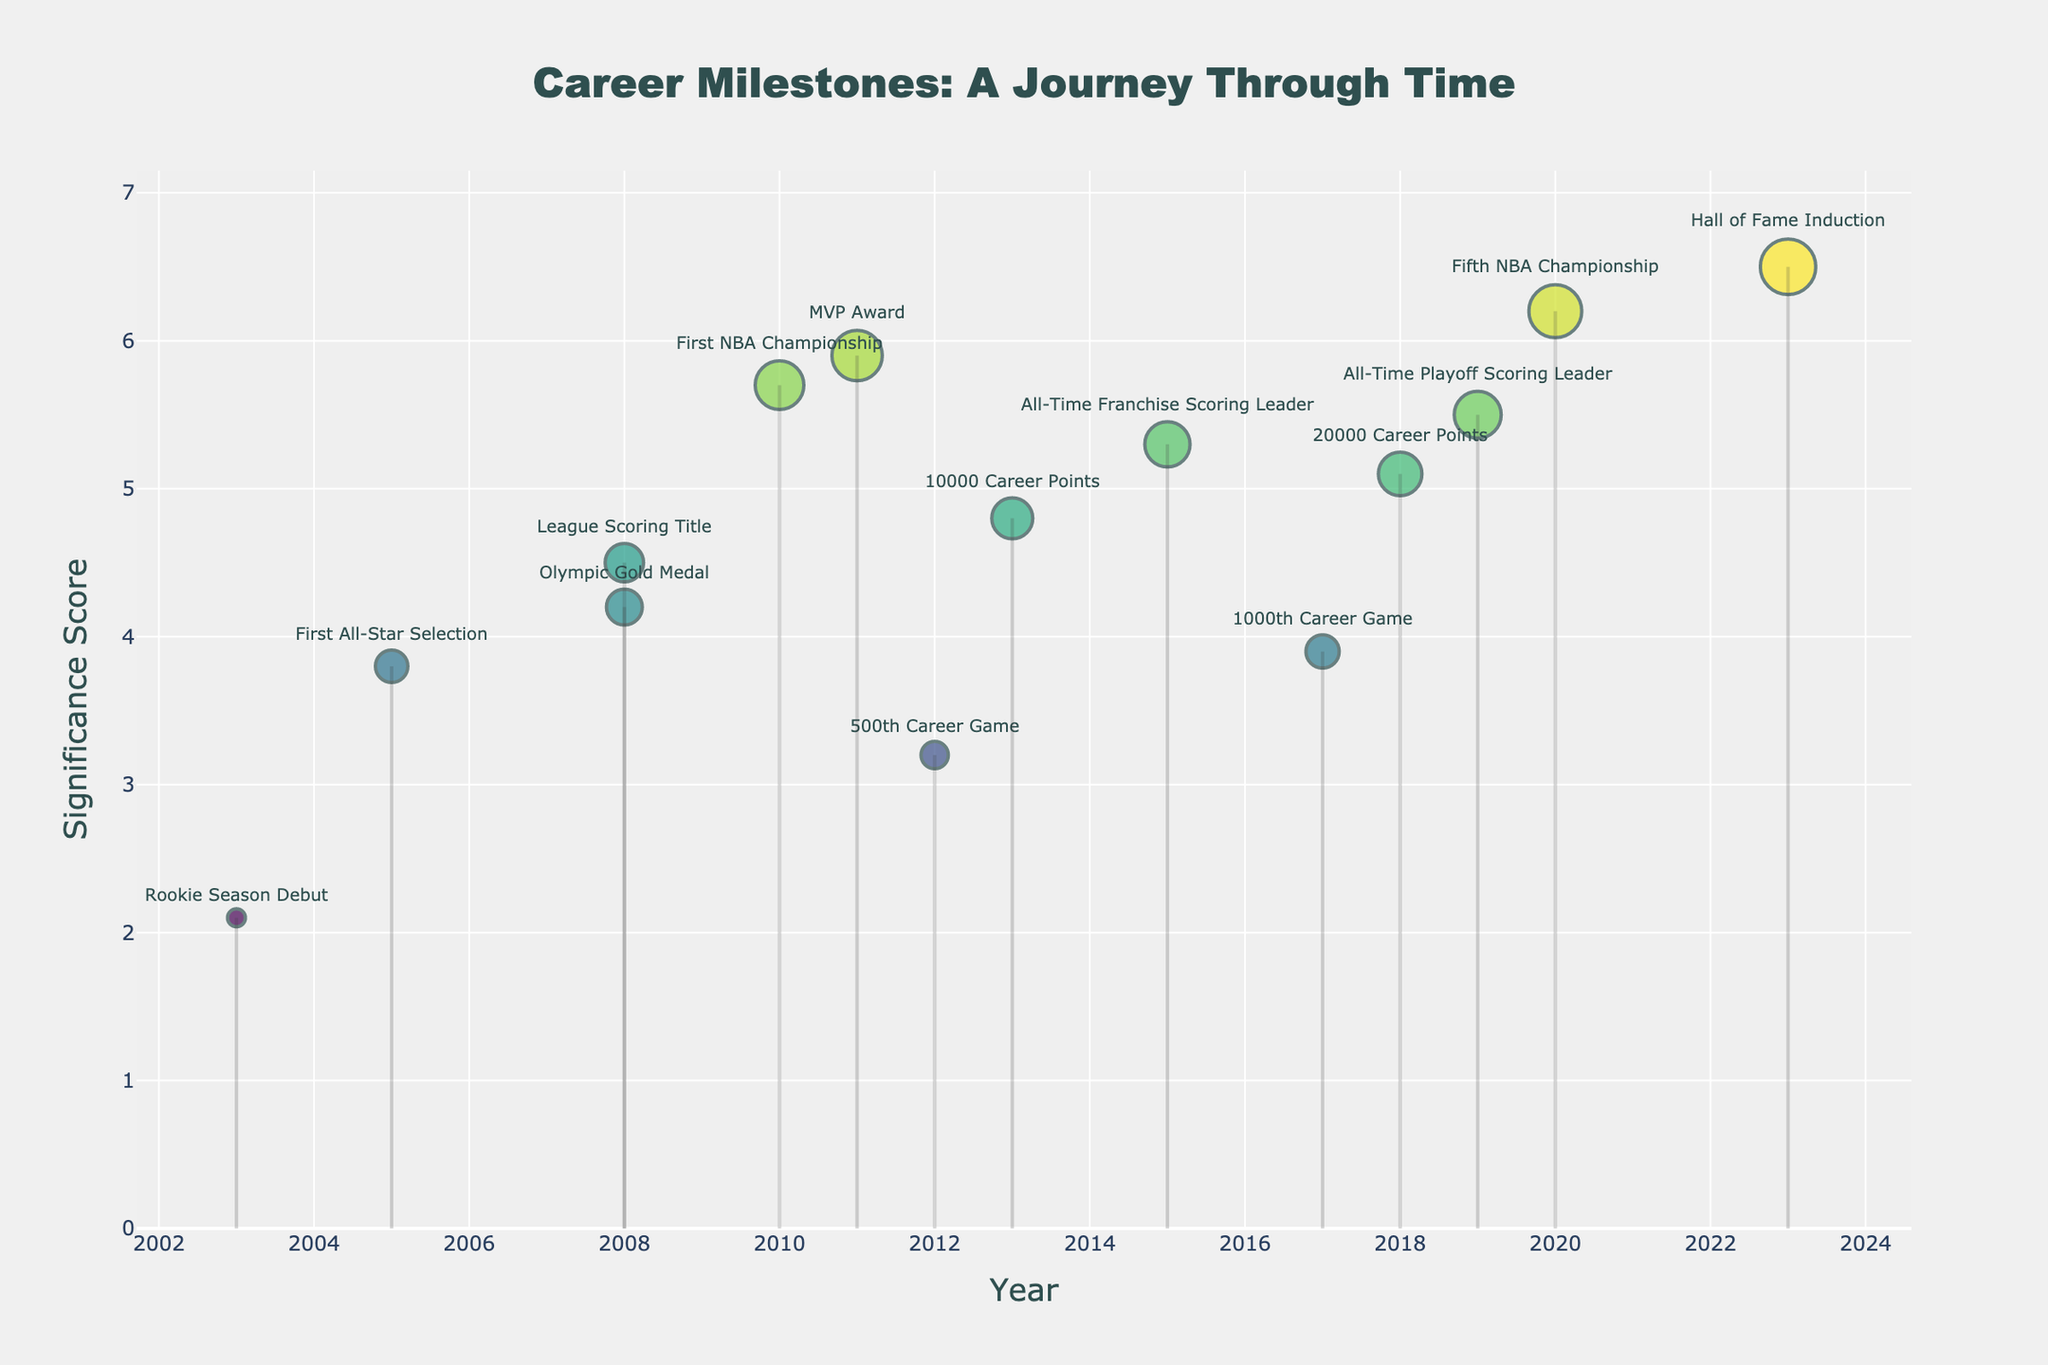What is the title of the plot? The title is usually positioned at the top of the plot. In this case, it reads "Career Milestones: A Journey Through Time".
Answer: Career Milestones: A Journey Through Time What is the significance score of the Hall of Fame Induction? The Hall of Fame Induction is one of the milestones labeled in the plot. The significance score associated with it can be found next to its marker.
Answer: 6.5 Which milestone has the highest significance score? By looking at all the markers on the plot, the one with the highest significance score will be the one with the greatest y-value. In this case, it is the Hall of Fame Induction.
Answer: Hall of Fame Induction How many milestones have a significance score greater than 5.0? Count the number of markers positioned above the significance score line of 5.0. These milestones include First NBA Championship, MVP Award, All-Time Franchise Scoring Leader, 20000 Career Points, All-Time Playoff Scoring Leader, Fifth NBA Championship, and Hall of Fame Induction. There are 7 such milestones.
Answer: 7 What year did the milestone with the lowest significance score occur? Identify the marker with the lowest significance score on the y-axis, which is the Rookie Season Debut, and check the corresponding year on the x-axis.
Answer: 2003 What is the difference in significance score between the MVP Award and the First All-Star Selection? Look for the significance scores of both MVP Award (2011) and First All-Star Selection (2005) in the plot. Subtract the score of First All-Star Selection from the MVP Award. The calculation is 5.9 - 3.8.
Answer: 2.1 Which milestone occurred in 2015 and what is its significance score? Locate the marker positioned at the year 2015 on the x-axis. The milestone is All-Time Franchise Scoring Leader, and the significance score is read from the y-axis.
Answer: All-Time Franchise Scoring Leader, 5.3 In what year did the milestone with a significance score of 4.8 occur? Find the marker at the y-axis value 4.8. The corresponding milestone is 10000 Career Points. Check the year on the x-axis for this marker.
Answer: 2013 Which milestone is closest in time to the milestone "500th Career Game"? Check the nearest x-axis markers around 2012. These markers are 10000 Career Points (2013) and MVP Award (2011). The nearer one is the MVP Award.
Answer: MVP Award What is the average significance score of the Olympic Gold Medal and League Scoring Title? First, find the significance scores of the Olympic Gold Medal (4.2) and League Scoring Title (4.5). The average is calculated as (4.2 + 4.5) / 2.
Answer: 4.35 